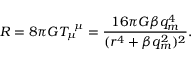Convert formula to latex. <formula><loc_0><loc_0><loc_500><loc_500>R = 8 \pi G T _ { \mu } ^ { \mu } = \frac { 1 6 \pi G \beta q _ { m } ^ { 4 } } { ( r ^ { 4 } + \beta q _ { m } ^ { 2 } ) ^ { 2 } } .</formula> 